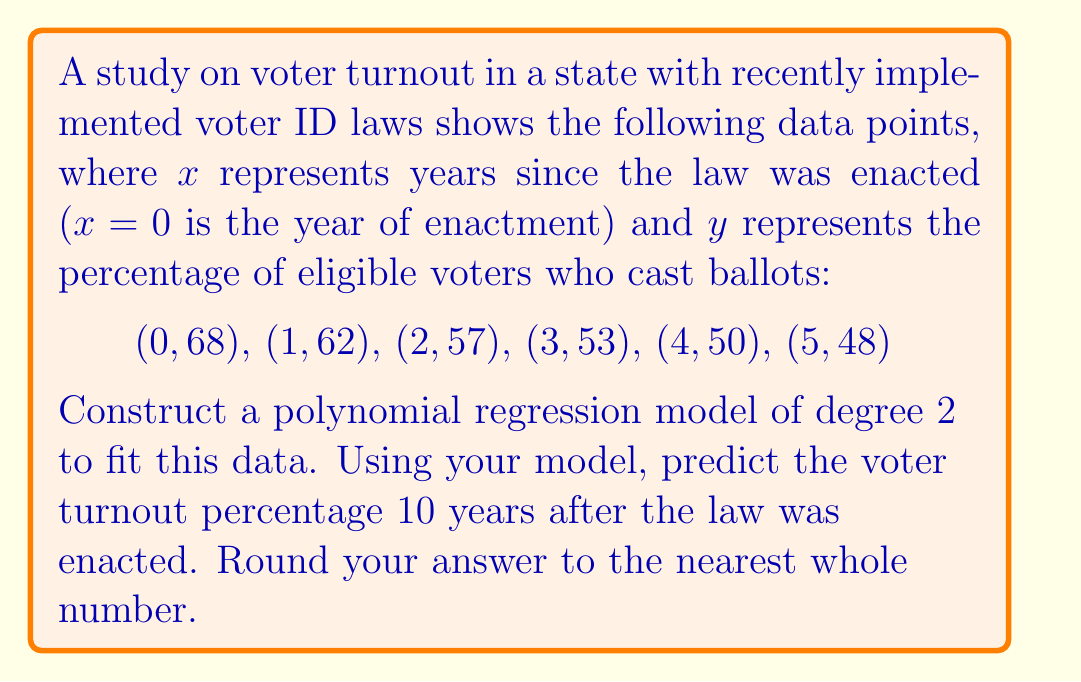Give your solution to this math problem. To construct a polynomial regression model of degree 2, we need to find the coefficients $a$, $b$, and $c$ for the equation $y = ax^2 + bx + c$.

1. Set up the system of normal equations:
   $$\begin{cases}
   \sum y = an\sum x^2 + b\sum x + nc \\
   \sum xy = a\sum x^3 + b\sum x^2 + c\sum x \\
   \sum x^2y = a\sum x^4 + b\sum x^3 + c\sum x^2
   \end{cases}$$

2. Calculate the necessary sums:
   $\sum x = 0 + 1 + 2 + 3 + 4 + 5 = 15$
   $\sum y = 68 + 62 + 57 + 53 + 50 + 48 = 338$
   $\sum x^2 = 0 + 1 + 4 + 9 + 16 + 25 = 55$
   $\sum x^3 = 0 + 1 + 8 + 27 + 64 + 125 = 225$
   $\sum x^4 = 0 + 1 + 16 + 81 + 256 + 625 = 979$
   $\sum xy = 0 + 62 + 114 + 159 + 200 + 240 = 775$
   $\sum x^2y = 0 + 62 + 228 + 477 + 800 + 1200 = 2767$

3. Substitute these values into the system of equations:
   $$\begin{cases}
   338 = 55a + 15b + 6c \\
   775 = 225a + 55b + 15c \\
   2767 = 979a + 225b + 55c
   \end{cases}$$

4. Solve this system of equations (using a calculator or computer algebra system) to get:
   $a \approx 0.5238$
   $b \approx -7.1548$
   $c \approx 67.7143$

5. The polynomial regression model is:
   $y = 0.5238x^2 - 7.1548x + 67.7143$

6. To predict the voter turnout 10 years after the law was enacted, substitute x = 10:
   $y = 0.5238(10)^2 - 7.1548(10) + 67.7143$
   $y = 52.38 - 71.548 + 67.7143$
   $y = 48.5463$

7. Rounding to the nearest whole number:
   $y \approx 49$
Answer: 49% 